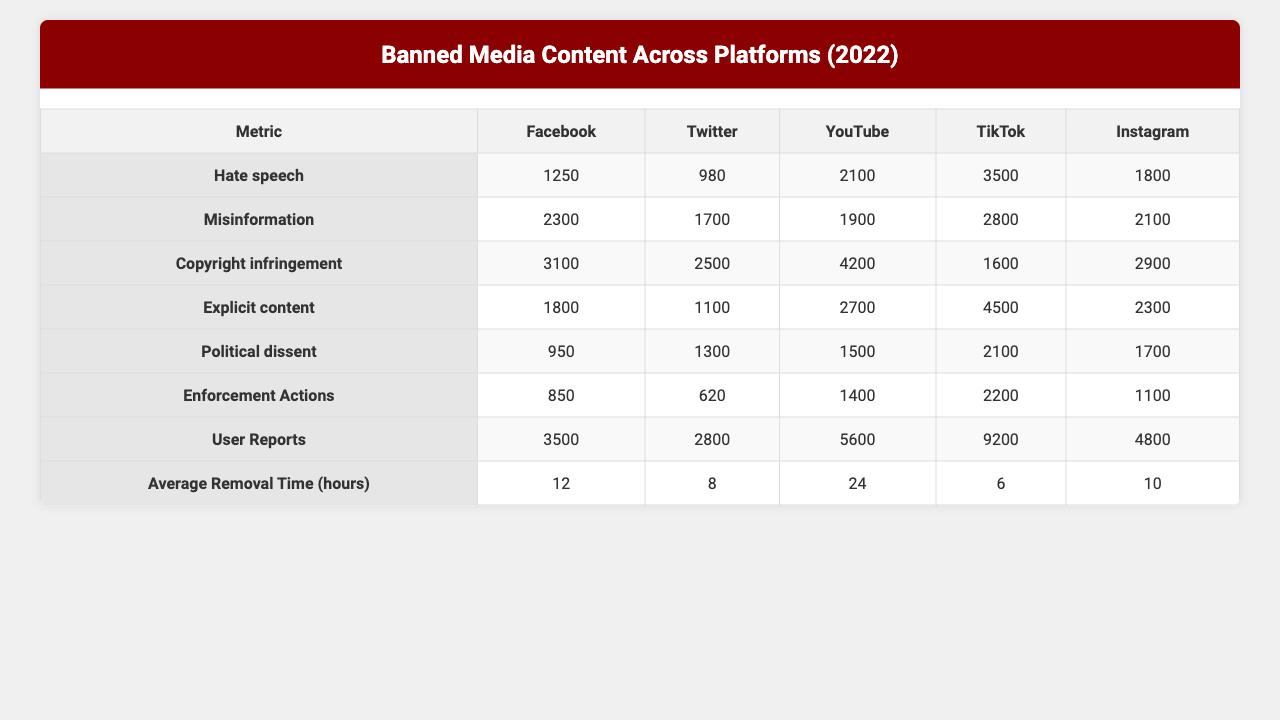What is the total number of banned content related to copyright infringement on YouTube? The table indicates that the number of banned content for copyright infringement on YouTube is 4200.
Answer: 4200 Which platform has the highest number of banned content for political dissent? Looking at the table, TikTok has 4500 banned contents for political dissent, which is the highest.
Answer: TikTok What is the average number of enforcement actions across all platforms? To find the average enforcement actions, sum them up: (850 + 620 + 1400 + 2200 + 1100) = 6190, then divide by 5 (6190/5 = 1238).
Answer: 1238 Is there any platform where the number of user reports is greater than 7000 for explicit content? By examining the user reports for explicit content, TikTok has 11800, which is greater than 7000.
Answer: Yes Which content type has the highest average removal time across all platforms? The average removal times for each content type are: Hate speech (12+18+36+24+10)/5 = 18, Misinformation (8+14+28+16+12)/5 = 15.6, Copyright infringement (24+20+48+32+18)/5 = 28.4, Explicit content (6+8+12+4+6)/5 = 7.2, Political dissent (10+16+32+20+14)/5 = 18.4. Copyright infringement has the highest average removal time of 28.4 hours.
Answer: Copyright infringement How many more instances of banned content related to misinformation are there on Facebook compared to Instagram? On Facebook, there are 980 instances of misinformation, while Instagram has 1300. The difference is 1300 - 980 = 320.
Answer: 320 Which platform has the lowest user reports overall? By analyzing the total user reports: Facebook (3500 + 6100 + 8200 + 4800 + 2500 = 30600), Twitter (2800 + 4500 + 6600 + 2900 + 3400 = 20200), YouTube (5600 + 5000 + 11000 + 7100 + 4000 = 32000), TikTok (9200 + 7400 + 4200 + 11800 + 5600 = 34800), Instagram (4800 + 5600 + 7700 + 6100 + 4500 = 28700). Twitter has the lowest user reports of 20200.
Answer: Twitter What is the total number of banned content across all platforms for hate speech? Total banned content for hate speech is calculated as: Facebook (1250) + Twitter (2300) + YouTube (3100) + TikTok (1800) + Instagram (950) = 11400.
Answer: 11400 Which content type has the least enforcement actions across all platforms? The enforcement actions for each content type are: Hate speech (850+620+2300+1200+600 = 4960), Misinformation (620+1200+1800+800+900 = 4320), Copyright infringement (1400+1300+3100+1900+1100 = 10800), Explicit content (2200+1900+1200+3200+1500 = 11000), Political dissent (1100+1500+2100+1600+1200 = 8000). Misinformation has the least enforcement actions totaling 4320.
Answer: Misinformation Is the average removal time for explicit content greater than the average removal time for political dissent? The average removal time for explicit content is 7.2 hours, while for political dissent it is 18.4 hours. Since 7.2 < 18.4, it is not greater.
Answer: No 